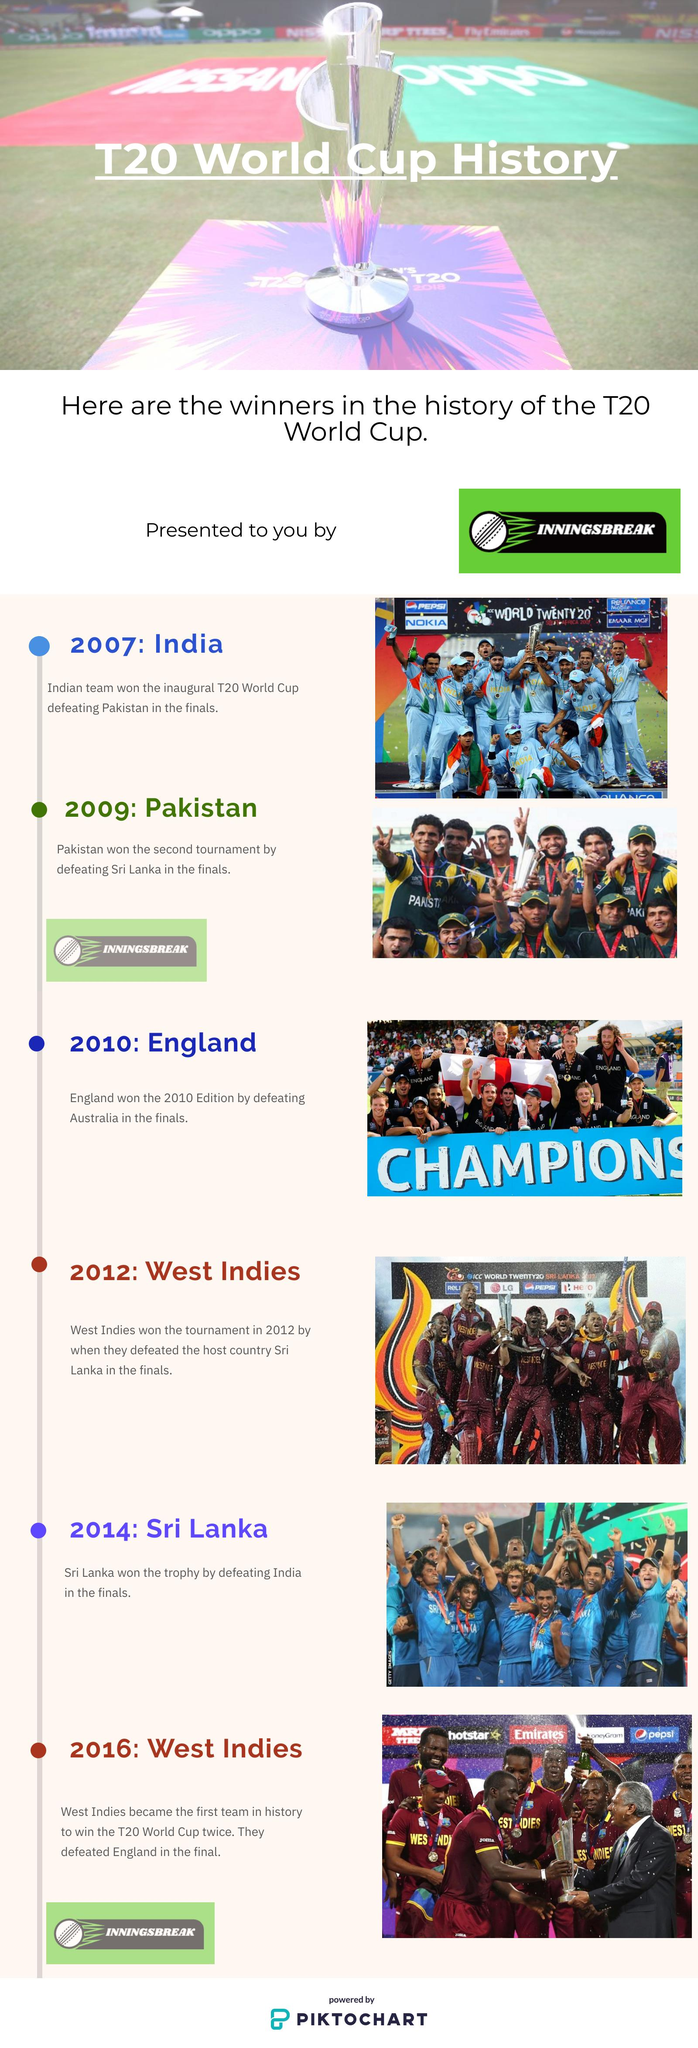Identify some key points in this picture. After England won the T20 World Cup, the West Indies team triumphed as the next champions. India has played two T20 World Cup final matches. India won the inaugural T20 World Cup. To date, there have been six T20 World Cup tournaments held. After India won the T20 World Cup, Pakistan took the title as the next champions. 